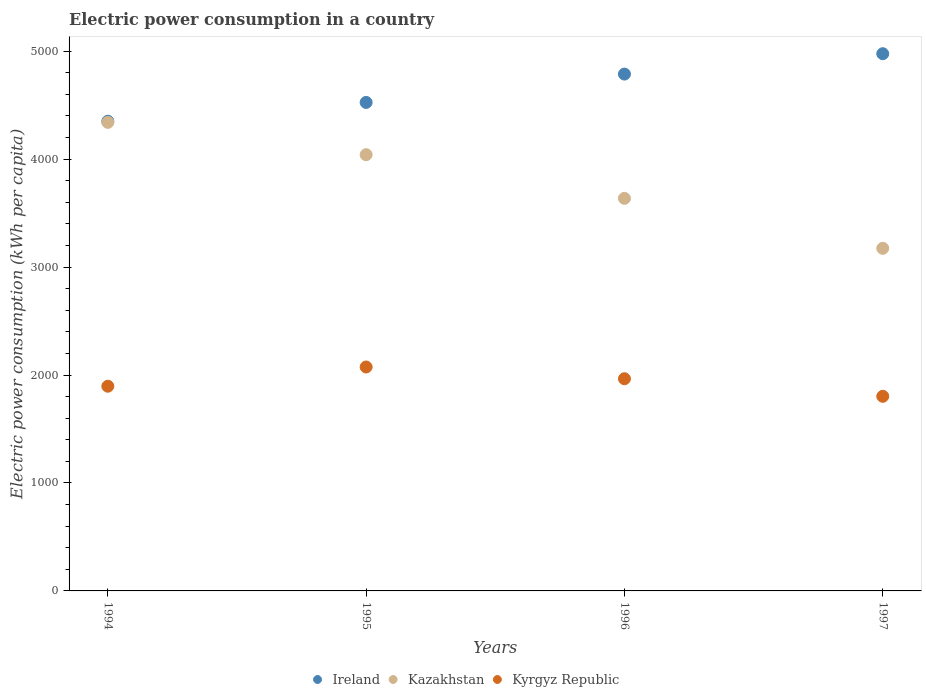How many different coloured dotlines are there?
Your answer should be very brief. 3. Is the number of dotlines equal to the number of legend labels?
Make the answer very short. Yes. What is the electric power consumption in in Kyrgyz Republic in 1994?
Make the answer very short. 1896.3. Across all years, what is the maximum electric power consumption in in Kyrgyz Republic?
Provide a succinct answer. 2074.38. Across all years, what is the minimum electric power consumption in in Kazakhstan?
Your answer should be very brief. 3173.79. What is the total electric power consumption in in Kyrgyz Republic in the graph?
Your answer should be compact. 7739.24. What is the difference between the electric power consumption in in Ireland in 1994 and that in 1997?
Your response must be concise. -625.57. What is the difference between the electric power consumption in in Ireland in 1997 and the electric power consumption in in Kyrgyz Republic in 1996?
Your response must be concise. 3010.94. What is the average electric power consumption in in Ireland per year?
Keep it short and to the point. 4660.22. In the year 1997, what is the difference between the electric power consumption in in Kazakhstan and electric power consumption in in Kyrgyz Republic?
Ensure brevity in your answer.  1370.92. In how many years, is the electric power consumption in in Kazakhstan greater than 1600 kWh per capita?
Keep it short and to the point. 4. What is the ratio of the electric power consumption in in Kyrgyz Republic in 1996 to that in 1997?
Ensure brevity in your answer.  1.09. Is the electric power consumption in in Kazakhstan in 1994 less than that in 1996?
Your answer should be very brief. No. What is the difference between the highest and the second highest electric power consumption in in Ireland?
Make the answer very short. 188.74. What is the difference between the highest and the lowest electric power consumption in in Ireland?
Keep it short and to the point. 625.57. Is it the case that in every year, the sum of the electric power consumption in in Ireland and electric power consumption in in Kazakhstan  is greater than the electric power consumption in in Kyrgyz Republic?
Give a very brief answer. Yes. Does the electric power consumption in in Kyrgyz Republic monotonically increase over the years?
Your answer should be very brief. No. Is the electric power consumption in in Ireland strictly less than the electric power consumption in in Kyrgyz Republic over the years?
Your response must be concise. No. How many dotlines are there?
Keep it short and to the point. 3. Does the graph contain any zero values?
Keep it short and to the point. No. How are the legend labels stacked?
Keep it short and to the point. Horizontal. What is the title of the graph?
Ensure brevity in your answer.  Electric power consumption in a country. Does "Azerbaijan" appear as one of the legend labels in the graph?
Offer a terse response. No. What is the label or title of the Y-axis?
Your response must be concise. Electric power consumption (kWh per capita). What is the Electric power consumption (kWh per capita) in Ireland in 1994?
Your response must be concise. 4351.06. What is the Electric power consumption (kWh per capita) of Kazakhstan in 1994?
Your response must be concise. 4340.74. What is the Electric power consumption (kWh per capita) in Kyrgyz Republic in 1994?
Offer a terse response. 1896.3. What is the Electric power consumption (kWh per capita) in Ireland in 1995?
Ensure brevity in your answer.  4525.28. What is the Electric power consumption (kWh per capita) in Kazakhstan in 1995?
Provide a short and direct response. 4041.13. What is the Electric power consumption (kWh per capita) in Kyrgyz Republic in 1995?
Offer a very short reply. 2074.38. What is the Electric power consumption (kWh per capita) of Ireland in 1996?
Provide a short and direct response. 4787.89. What is the Electric power consumption (kWh per capita) of Kazakhstan in 1996?
Your answer should be very brief. 3636.63. What is the Electric power consumption (kWh per capita) of Kyrgyz Republic in 1996?
Keep it short and to the point. 1965.69. What is the Electric power consumption (kWh per capita) in Ireland in 1997?
Keep it short and to the point. 4976.63. What is the Electric power consumption (kWh per capita) in Kazakhstan in 1997?
Offer a very short reply. 3173.79. What is the Electric power consumption (kWh per capita) of Kyrgyz Republic in 1997?
Offer a terse response. 1802.87. Across all years, what is the maximum Electric power consumption (kWh per capita) in Ireland?
Your response must be concise. 4976.63. Across all years, what is the maximum Electric power consumption (kWh per capita) of Kazakhstan?
Provide a succinct answer. 4340.74. Across all years, what is the maximum Electric power consumption (kWh per capita) in Kyrgyz Republic?
Offer a very short reply. 2074.38. Across all years, what is the minimum Electric power consumption (kWh per capita) in Ireland?
Provide a succinct answer. 4351.06. Across all years, what is the minimum Electric power consumption (kWh per capita) of Kazakhstan?
Your response must be concise. 3173.79. Across all years, what is the minimum Electric power consumption (kWh per capita) of Kyrgyz Republic?
Make the answer very short. 1802.87. What is the total Electric power consumption (kWh per capita) in Ireland in the graph?
Keep it short and to the point. 1.86e+04. What is the total Electric power consumption (kWh per capita) of Kazakhstan in the graph?
Your answer should be compact. 1.52e+04. What is the total Electric power consumption (kWh per capita) in Kyrgyz Republic in the graph?
Your answer should be compact. 7739.24. What is the difference between the Electric power consumption (kWh per capita) of Ireland in 1994 and that in 1995?
Your response must be concise. -174.21. What is the difference between the Electric power consumption (kWh per capita) of Kazakhstan in 1994 and that in 1995?
Offer a very short reply. 299.61. What is the difference between the Electric power consumption (kWh per capita) in Kyrgyz Republic in 1994 and that in 1995?
Ensure brevity in your answer.  -178.08. What is the difference between the Electric power consumption (kWh per capita) in Ireland in 1994 and that in 1996?
Make the answer very short. -436.83. What is the difference between the Electric power consumption (kWh per capita) in Kazakhstan in 1994 and that in 1996?
Your answer should be compact. 704.11. What is the difference between the Electric power consumption (kWh per capita) in Kyrgyz Republic in 1994 and that in 1996?
Your answer should be very brief. -69.39. What is the difference between the Electric power consumption (kWh per capita) of Ireland in 1994 and that in 1997?
Your response must be concise. -625.57. What is the difference between the Electric power consumption (kWh per capita) of Kazakhstan in 1994 and that in 1997?
Provide a short and direct response. 1166.94. What is the difference between the Electric power consumption (kWh per capita) in Kyrgyz Republic in 1994 and that in 1997?
Ensure brevity in your answer.  93.43. What is the difference between the Electric power consumption (kWh per capita) of Ireland in 1995 and that in 1996?
Ensure brevity in your answer.  -262.62. What is the difference between the Electric power consumption (kWh per capita) in Kazakhstan in 1995 and that in 1996?
Provide a succinct answer. 404.5. What is the difference between the Electric power consumption (kWh per capita) of Kyrgyz Republic in 1995 and that in 1996?
Provide a short and direct response. 108.69. What is the difference between the Electric power consumption (kWh per capita) of Ireland in 1995 and that in 1997?
Ensure brevity in your answer.  -451.36. What is the difference between the Electric power consumption (kWh per capita) in Kazakhstan in 1995 and that in 1997?
Offer a terse response. 867.34. What is the difference between the Electric power consumption (kWh per capita) in Kyrgyz Republic in 1995 and that in 1997?
Make the answer very short. 271.51. What is the difference between the Electric power consumption (kWh per capita) in Ireland in 1996 and that in 1997?
Your answer should be very brief. -188.74. What is the difference between the Electric power consumption (kWh per capita) of Kazakhstan in 1996 and that in 1997?
Offer a very short reply. 462.83. What is the difference between the Electric power consumption (kWh per capita) of Kyrgyz Republic in 1996 and that in 1997?
Offer a very short reply. 162.82. What is the difference between the Electric power consumption (kWh per capita) of Ireland in 1994 and the Electric power consumption (kWh per capita) of Kazakhstan in 1995?
Your response must be concise. 309.93. What is the difference between the Electric power consumption (kWh per capita) of Ireland in 1994 and the Electric power consumption (kWh per capita) of Kyrgyz Republic in 1995?
Your answer should be compact. 2276.68. What is the difference between the Electric power consumption (kWh per capita) in Kazakhstan in 1994 and the Electric power consumption (kWh per capita) in Kyrgyz Republic in 1995?
Provide a succinct answer. 2266.36. What is the difference between the Electric power consumption (kWh per capita) of Ireland in 1994 and the Electric power consumption (kWh per capita) of Kazakhstan in 1996?
Ensure brevity in your answer.  714.44. What is the difference between the Electric power consumption (kWh per capita) in Ireland in 1994 and the Electric power consumption (kWh per capita) in Kyrgyz Republic in 1996?
Ensure brevity in your answer.  2385.37. What is the difference between the Electric power consumption (kWh per capita) of Kazakhstan in 1994 and the Electric power consumption (kWh per capita) of Kyrgyz Republic in 1996?
Your answer should be compact. 2375.05. What is the difference between the Electric power consumption (kWh per capita) of Ireland in 1994 and the Electric power consumption (kWh per capita) of Kazakhstan in 1997?
Offer a terse response. 1177.27. What is the difference between the Electric power consumption (kWh per capita) of Ireland in 1994 and the Electric power consumption (kWh per capita) of Kyrgyz Republic in 1997?
Your response must be concise. 2548.19. What is the difference between the Electric power consumption (kWh per capita) in Kazakhstan in 1994 and the Electric power consumption (kWh per capita) in Kyrgyz Republic in 1997?
Provide a succinct answer. 2537.87. What is the difference between the Electric power consumption (kWh per capita) in Ireland in 1995 and the Electric power consumption (kWh per capita) in Kazakhstan in 1996?
Offer a terse response. 888.65. What is the difference between the Electric power consumption (kWh per capita) in Ireland in 1995 and the Electric power consumption (kWh per capita) in Kyrgyz Republic in 1996?
Your answer should be compact. 2559.59. What is the difference between the Electric power consumption (kWh per capita) of Kazakhstan in 1995 and the Electric power consumption (kWh per capita) of Kyrgyz Republic in 1996?
Provide a short and direct response. 2075.44. What is the difference between the Electric power consumption (kWh per capita) in Ireland in 1995 and the Electric power consumption (kWh per capita) in Kazakhstan in 1997?
Make the answer very short. 1351.48. What is the difference between the Electric power consumption (kWh per capita) of Ireland in 1995 and the Electric power consumption (kWh per capita) of Kyrgyz Republic in 1997?
Your answer should be compact. 2722.41. What is the difference between the Electric power consumption (kWh per capita) in Kazakhstan in 1995 and the Electric power consumption (kWh per capita) in Kyrgyz Republic in 1997?
Provide a short and direct response. 2238.26. What is the difference between the Electric power consumption (kWh per capita) of Ireland in 1996 and the Electric power consumption (kWh per capita) of Kazakhstan in 1997?
Offer a very short reply. 1614.1. What is the difference between the Electric power consumption (kWh per capita) in Ireland in 1996 and the Electric power consumption (kWh per capita) in Kyrgyz Republic in 1997?
Your answer should be compact. 2985.02. What is the difference between the Electric power consumption (kWh per capita) in Kazakhstan in 1996 and the Electric power consumption (kWh per capita) in Kyrgyz Republic in 1997?
Offer a very short reply. 1833.76. What is the average Electric power consumption (kWh per capita) of Ireland per year?
Keep it short and to the point. 4660.22. What is the average Electric power consumption (kWh per capita) of Kazakhstan per year?
Provide a succinct answer. 3798.07. What is the average Electric power consumption (kWh per capita) of Kyrgyz Republic per year?
Your answer should be very brief. 1934.81. In the year 1994, what is the difference between the Electric power consumption (kWh per capita) in Ireland and Electric power consumption (kWh per capita) in Kazakhstan?
Ensure brevity in your answer.  10.33. In the year 1994, what is the difference between the Electric power consumption (kWh per capita) in Ireland and Electric power consumption (kWh per capita) in Kyrgyz Republic?
Ensure brevity in your answer.  2454.76. In the year 1994, what is the difference between the Electric power consumption (kWh per capita) in Kazakhstan and Electric power consumption (kWh per capita) in Kyrgyz Republic?
Ensure brevity in your answer.  2444.43. In the year 1995, what is the difference between the Electric power consumption (kWh per capita) of Ireland and Electric power consumption (kWh per capita) of Kazakhstan?
Make the answer very short. 484.15. In the year 1995, what is the difference between the Electric power consumption (kWh per capita) in Ireland and Electric power consumption (kWh per capita) in Kyrgyz Republic?
Make the answer very short. 2450.9. In the year 1995, what is the difference between the Electric power consumption (kWh per capita) of Kazakhstan and Electric power consumption (kWh per capita) of Kyrgyz Republic?
Your answer should be very brief. 1966.75. In the year 1996, what is the difference between the Electric power consumption (kWh per capita) in Ireland and Electric power consumption (kWh per capita) in Kazakhstan?
Keep it short and to the point. 1151.26. In the year 1996, what is the difference between the Electric power consumption (kWh per capita) of Ireland and Electric power consumption (kWh per capita) of Kyrgyz Republic?
Your response must be concise. 2822.2. In the year 1996, what is the difference between the Electric power consumption (kWh per capita) of Kazakhstan and Electric power consumption (kWh per capita) of Kyrgyz Republic?
Your response must be concise. 1670.94. In the year 1997, what is the difference between the Electric power consumption (kWh per capita) of Ireland and Electric power consumption (kWh per capita) of Kazakhstan?
Your answer should be compact. 1802.84. In the year 1997, what is the difference between the Electric power consumption (kWh per capita) of Ireland and Electric power consumption (kWh per capita) of Kyrgyz Republic?
Your answer should be compact. 3173.76. In the year 1997, what is the difference between the Electric power consumption (kWh per capita) of Kazakhstan and Electric power consumption (kWh per capita) of Kyrgyz Republic?
Your response must be concise. 1370.92. What is the ratio of the Electric power consumption (kWh per capita) of Ireland in 1994 to that in 1995?
Offer a very short reply. 0.96. What is the ratio of the Electric power consumption (kWh per capita) of Kazakhstan in 1994 to that in 1995?
Your response must be concise. 1.07. What is the ratio of the Electric power consumption (kWh per capita) in Kyrgyz Republic in 1994 to that in 1995?
Keep it short and to the point. 0.91. What is the ratio of the Electric power consumption (kWh per capita) of Ireland in 1994 to that in 1996?
Ensure brevity in your answer.  0.91. What is the ratio of the Electric power consumption (kWh per capita) in Kazakhstan in 1994 to that in 1996?
Provide a succinct answer. 1.19. What is the ratio of the Electric power consumption (kWh per capita) in Kyrgyz Republic in 1994 to that in 1996?
Ensure brevity in your answer.  0.96. What is the ratio of the Electric power consumption (kWh per capita) of Ireland in 1994 to that in 1997?
Your answer should be compact. 0.87. What is the ratio of the Electric power consumption (kWh per capita) of Kazakhstan in 1994 to that in 1997?
Provide a succinct answer. 1.37. What is the ratio of the Electric power consumption (kWh per capita) in Kyrgyz Republic in 1994 to that in 1997?
Make the answer very short. 1.05. What is the ratio of the Electric power consumption (kWh per capita) in Ireland in 1995 to that in 1996?
Provide a short and direct response. 0.95. What is the ratio of the Electric power consumption (kWh per capita) of Kazakhstan in 1995 to that in 1996?
Offer a very short reply. 1.11. What is the ratio of the Electric power consumption (kWh per capita) of Kyrgyz Republic in 1995 to that in 1996?
Give a very brief answer. 1.06. What is the ratio of the Electric power consumption (kWh per capita) of Ireland in 1995 to that in 1997?
Provide a succinct answer. 0.91. What is the ratio of the Electric power consumption (kWh per capita) of Kazakhstan in 1995 to that in 1997?
Offer a very short reply. 1.27. What is the ratio of the Electric power consumption (kWh per capita) in Kyrgyz Republic in 1995 to that in 1997?
Provide a succinct answer. 1.15. What is the ratio of the Electric power consumption (kWh per capita) in Ireland in 1996 to that in 1997?
Your response must be concise. 0.96. What is the ratio of the Electric power consumption (kWh per capita) of Kazakhstan in 1996 to that in 1997?
Offer a very short reply. 1.15. What is the ratio of the Electric power consumption (kWh per capita) of Kyrgyz Republic in 1996 to that in 1997?
Your answer should be compact. 1.09. What is the difference between the highest and the second highest Electric power consumption (kWh per capita) of Ireland?
Keep it short and to the point. 188.74. What is the difference between the highest and the second highest Electric power consumption (kWh per capita) of Kazakhstan?
Offer a terse response. 299.61. What is the difference between the highest and the second highest Electric power consumption (kWh per capita) in Kyrgyz Republic?
Keep it short and to the point. 108.69. What is the difference between the highest and the lowest Electric power consumption (kWh per capita) in Ireland?
Make the answer very short. 625.57. What is the difference between the highest and the lowest Electric power consumption (kWh per capita) in Kazakhstan?
Your answer should be compact. 1166.94. What is the difference between the highest and the lowest Electric power consumption (kWh per capita) of Kyrgyz Republic?
Offer a terse response. 271.51. 